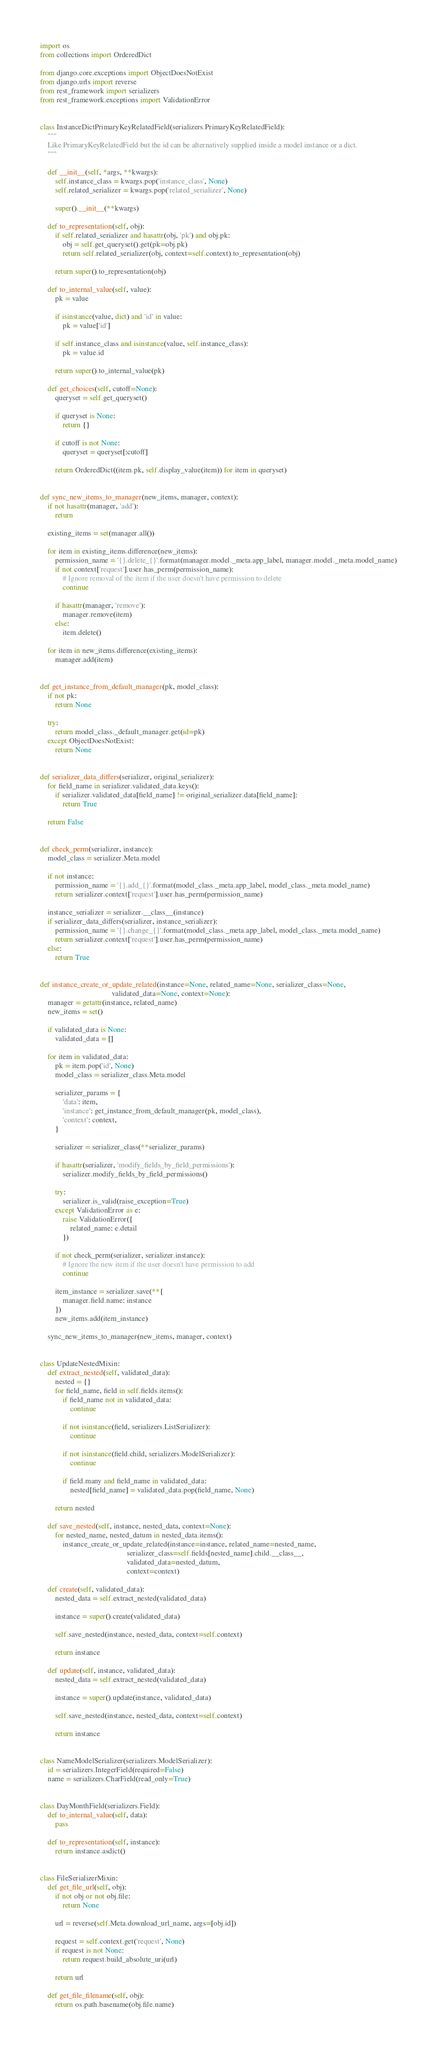Convert code to text. <code><loc_0><loc_0><loc_500><loc_500><_Python_>import os
from collections import OrderedDict

from django.core.exceptions import ObjectDoesNotExist
from django.urls import reverse
from rest_framework import serializers
from rest_framework.exceptions import ValidationError


class InstanceDictPrimaryKeyRelatedField(serializers.PrimaryKeyRelatedField):
    """
    Like PrimaryKeyRelatedField but the id can be alternatively supplied inside a model instance or a dict.
    """

    def __init__(self, *args, **kwargs):
        self.instance_class = kwargs.pop('instance_class', None)
        self.related_serializer = kwargs.pop('related_serializer', None)

        super().__init__(**kwargs)

    def to_representation(self, obj):
        if self.related_serializer and hasattr(obj, 'pk') and obj.pk:
            obj = self.get_queryset().get(pk=obj.pk)
            return self.related_serializer(obj, context=self.context).to_representation(obj)

        return super().to_representation(obj)

    def to_internal_value(self, value):
        pk = value

        if isinstance(value, dict) and 'id' in value:
            pk = value['id']

        if self.instance_class and isinstance(value, self.instance_class):
            pk = value.id

        return super().to_internal_value(pk)

    def get_choices(self, cutoff=None):
        queryset = self.get_queryset()

        if queryset is None:
            return {}

        if cutoff is not None:
            queryset = queryset[:cutoff]

        return OrderedDict((item.pk, self.display_value(item)) for item in queryset)


def sync_new_items_to_manager(new_items, manager, context):
    if not hasattr(manager, 'add'):
        return

    existing_items = set(manager.all())

    for item in existing_items.difference(new_items):
        permission_name = '{}.delete_{}'.format(manager.model._meta.app_label, manager.model._meta.model_name)
        if not context['request'].user.has_perm(permission_name):
            # Ignore removal of the item if the user doesn't have permission to delete
            continue

        if hasattr(manager, 'remove'):
            manager.remove(item)
        else:
            item.delete()

    for item in new_items.difference(existing_items):
        manager.add(item)


def get_instance_from_default_manager(pk, model_class):
    if not pk:
        return None

    try:
        return model_class._default_manager.get(id=pk)
    except ObjectDoesNotExist:
        return None


def serializer_data_differs(serializer, original_serializer):
    for field_name in serializer.validated_data.keys():
        if serializer.validated_data[field_name] != original_serializer.data[field_name]:
            return True

    return False


def check_perm(serializer, instance):
    model_class = serializer.Meta.model

    if not instance:
        permission_name = '{}.add_{}'.format(model_class._meta.app_label, model_class._meta.model_name)
        return serializer.context['request'].user.has_perm(permission_name)

    instance_serializer = serializer.__class__(instance)
    if serializer_data_differs(serializer, instance_serializer):
        permission_name = '{}.change_{}'.format(model_class._meta.app_label, model_class._meta.model_name)
        return serializer.context['request'].user.has_perm(permission_name)
    else:
        return True


def instance_create_or_update_related(instance=None, related_name=None, serializer_class=None,
                                      validated_data=None, context=None):
    manager = getattr(instance, related_name)
    new_items = set()

    if validated_data is None:
        validated_data = []

    for item in validated_data:
        pk = item.pop('id', None)
        model_class = serializer_class.Meta.model

        serializer_params = {
            'data': item,
            'instance': get_instance_from_default_manager(pk, model_class),
            'context': context,
        }

        serializer = serializer_class(**serializer_params)

        if hasattr(serializer, 'modify_fields_by_field_permissions'):
            serializer.modify_fields_by_field_permissions()

        try:
            serializer.is_valid(raise_exception=True)
        except ValidationError as e:
            raise ValidationError({
                related_name: e.detail
            })

        if not check_perm(serializer, serializer.instance):
            # Ignore the new item if the user doesn't have permission to add
            continue

        item_instance = serializer.save(**{
            manager.field.name: instance
        })
        new_items.add(item_instance)

    sync_new_items_to_manager(new_items, manager, context)


class UpdateNestedMixin:
    def extract_nested(self, validated_data):
        nested = {}
        for field_name, field in self.fields.items():
            if field_name not in validated_data:
                continue

            if not isinstance(field, serializers.ListSerializer):
                continue

            if not isinstance(field.child, serializers.ModelSerializer):
                continue

            if field.many and field_name in validated_data:
                nested[field_name] = validated_data.pop(field_name, None)

        return nested

    def save_nested(self, instance, nested_data, context=None):
        for nested_name, nested_datum in nested_data.items():
            instance_create_or_update_related(instance=instance, related_name=nested_name,
                                              serializer_class=self.fields[nested_name].child.__class__,
                                              validated_data=nested_datum,
                                              context=context)

    def create(self, validated_data):
        nested_data = self.extract_nested(validated_data)

        instance = super().create(validated_data)

        self.save_nested(instance, nested_data, context=self.context)

        return instance

    def update(self, instance, validated_data):
        nested_data = self.extract_nested(validated_data)

        instance = super().update(instance, validated_data)

        self.save_nested(instance, nested_data, context=self.context)

        return instance


class NameModelSerializer(serializers.ModelSerializer):
    id = serializers.IntegerField(required=False)
    name = serializers.CharField(read_only=True)


class DayMonthField(serializers.Field):
    def to_internal_value(self, data):
        pass

    def to_representation(self, instance):
        return instance.asdict()


class FileSerializerMixin:
    def get_file_url(self, obj):
        if not obj or not obj.file:
            return None

        url = reverse(self.Meta.download_url_name, args=[obj.id])

        request = self.context.get('request', None)
        if request is not None:
            return request.build_absolute_uri(url)

        return url

    def get_file_filename(self, obj):
        return os.path.basename(obj.file.name)
</code> 